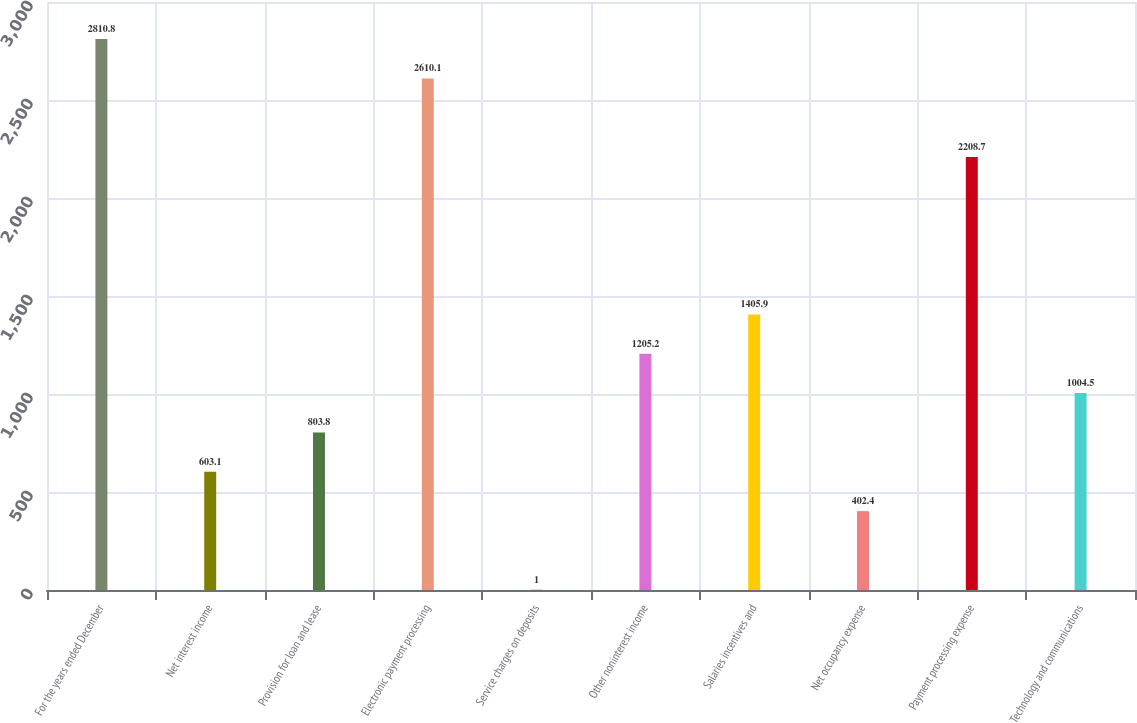Convert chart. <chart><loc_0><loc_0><loc_500><loc_500><bar_chart><fcel>For the years ended December<fcel>Net interest income<fcel>Provision for loan and lease<fcel>Electronic payment processing<fcel>Service charges on deposits<fcel>Other noninterest income<fcel>Salaries incentives and<fcel>Net occupancy expense<fcel>Payment processing expense<fcel>Technology and communications<nl><fcel>2810.8<fcel>603.1<fcel>803.8<fcel>2610.1<fcel>1<fcel>1205.2<fcel>1405.9<fcel>402.4<fcel>2208.7<fcel>1004.5<nl></chart> 